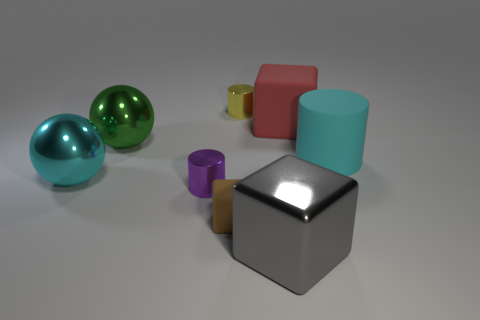Add 2 matte blocks. How many objects exist? 10 Subtract all cylinders. How many objects are left? 5 Add 1 tiny purple objects. How many tiny purple objects exist? 2 Subtract 1 yellow cylinders. How many objects are left? 7 Subtract all tiny green metal cubes. Subtract all cyan rubber objects. How many objects are left? 7 Add 3 gray metallic objects. How many gray metallic objects are left? 4 